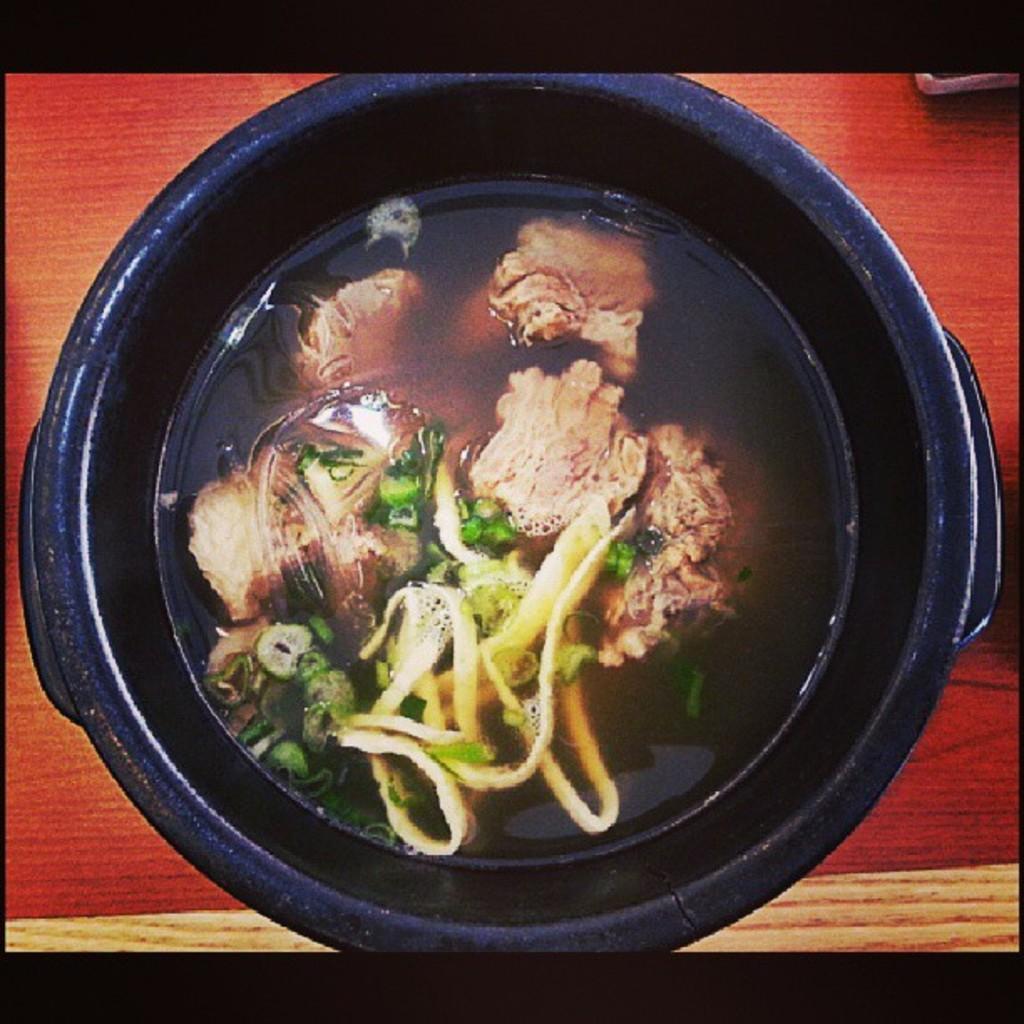Please provide a concise description of this image. In this picture we can see a bowl on the wooden surface with food in it. 